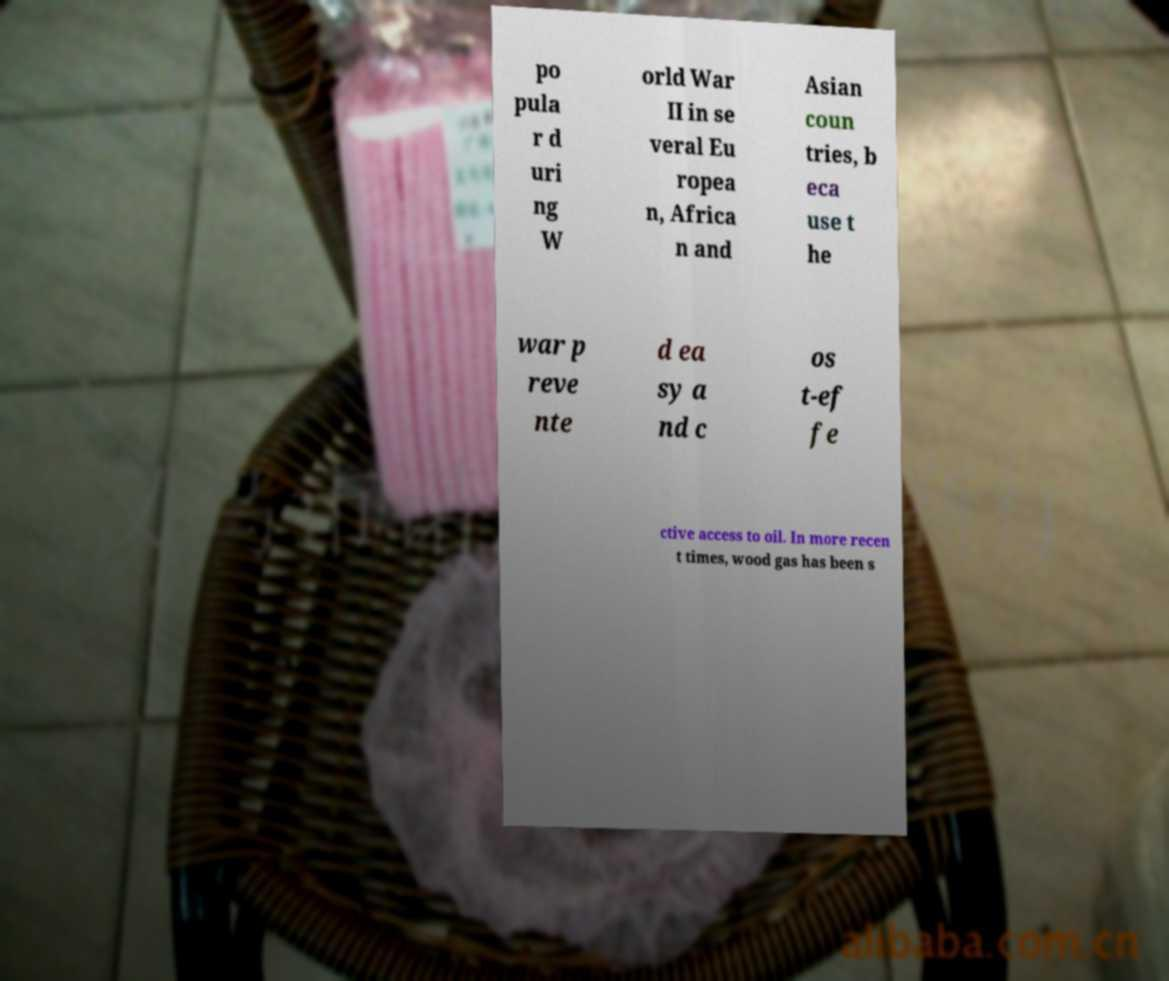For documentation purposes, I need the text within this image transcribed. Could you provide that? po pula r d uri ng W orld War II in se veral Eu ropea n, Africa n and Asian coun tries, b eca use t he war p reve nte d ea sy a nd c os t-ef fe ctive access to oil. In more recen t times, wood gas has been s 